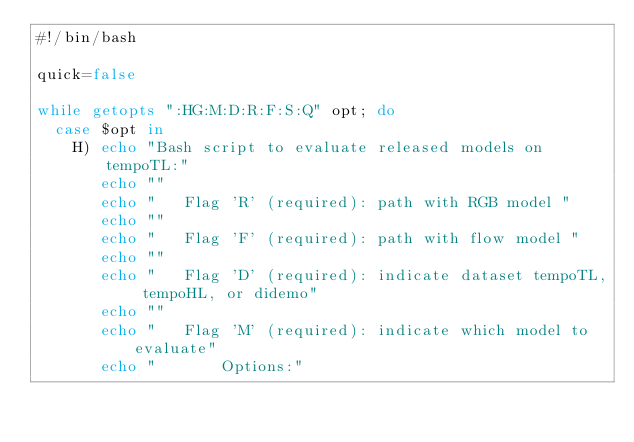Convert code to text. <code><loc_0><loc_0><loc_500><loc_500><_Bash_>#!/bin/bash

quick=false

while getopts ":HG:M:D:R:F:S:Q" opt; do
  case $opt in
    H) echo "Bash script to evaluate released models on tempoTL:"
       echo ""
       echo "   Flag 'R' (required): path with RGB model "
       echo ""
       echo "   Flag 'F' (required): path with flow model "
       echo ""
       echo "   Flag 'D' (required): indicate dataset tempoTL, tempoHL, or didemo"
       echo ""
       echo "   Flag 'M' (required): indicate which model to evaluate"
       echo "       Options:"</code> 